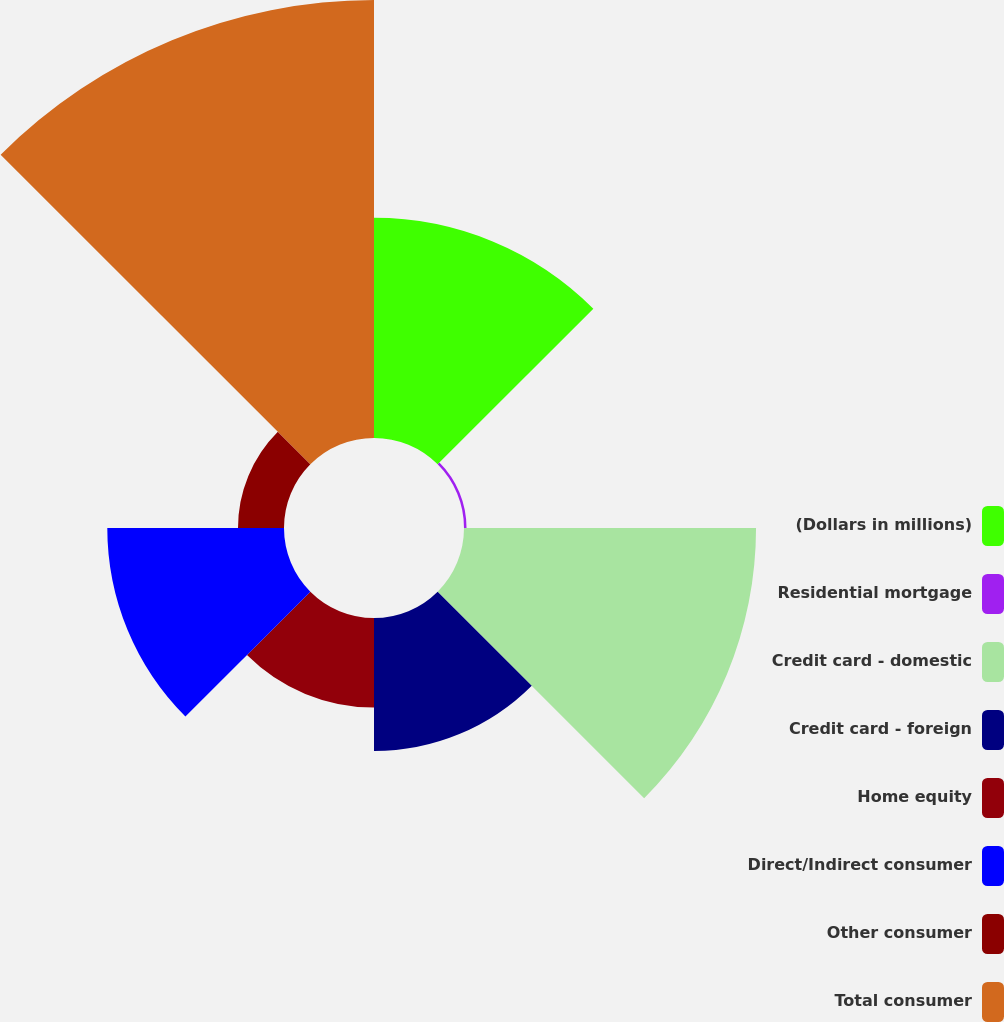Convert chart to OTSL. <chart><loc_0><loc_0><loc_500><loc_500><pie_chart><fcel>(Dollars in millions)<fcel>Residential mortgage<fcel>Credit card - domestic<fcel>Credit card - foreign<fcel>Home equity<fcel>Direct/Indirect consumer<fcel>Other consumer<fcel>Total consumer<nl><fcel>15.75%<fcel>0.18%<fcel>20.89%<fcel>9.52%<fcel>6.41%<fcel>12.64%<fcel>3.29%<fcel>31.33%<nl></chart> 